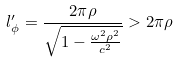Convert formula to latex. <formula><loc_0><loc_0><loc_500><loc_500>l ^ { \prime } _ { \phi } = \frac { 2 \pi \rho } { \sqrt { 1 - \frac { \omega ^ { 2 } \rho ^ { 2 } } { c ^ { 2 } } } } > 2 \pi \rho</formula> 